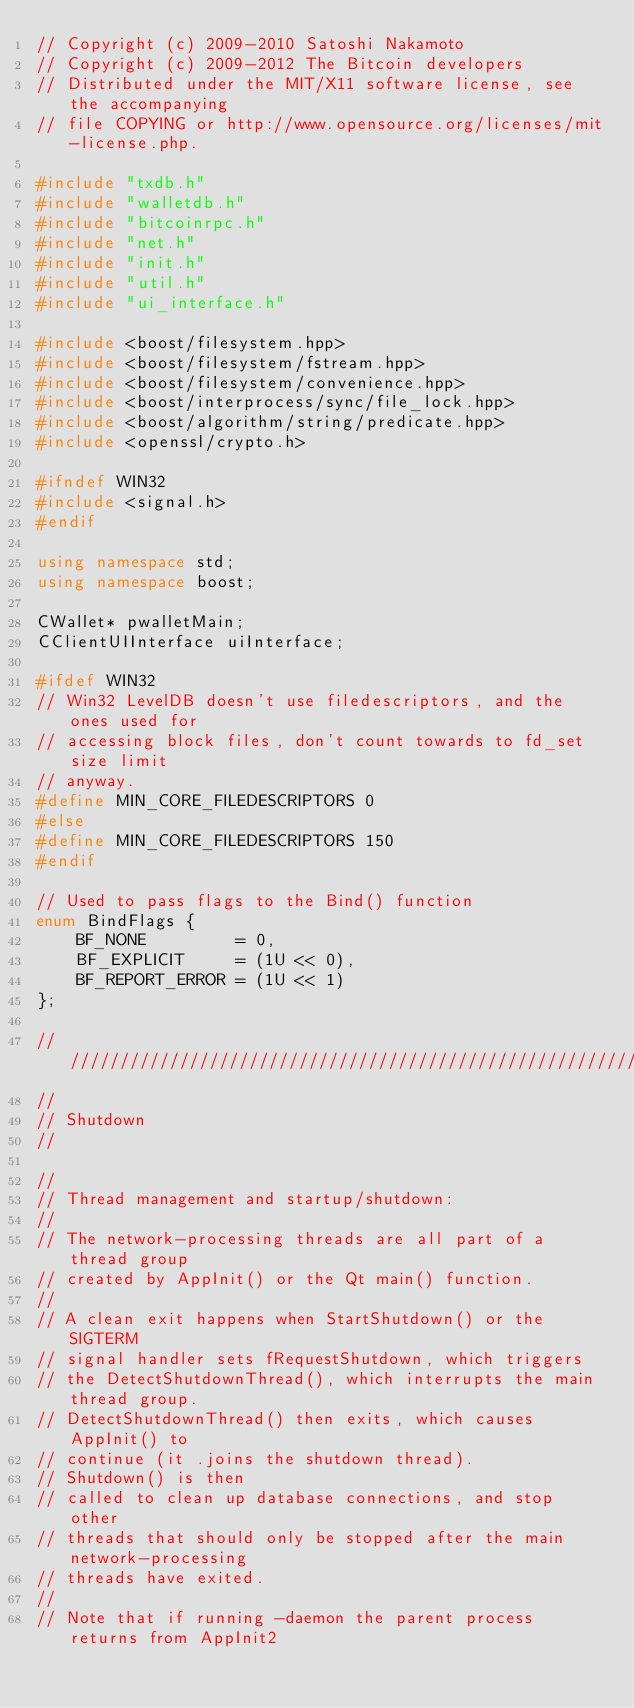Convert code to text. <code><loc_0><loc_0><loc_500><loc_500><_C++_>// Copyright (c) 2009-2010 Satoshi Nakamoto
// Copyright (c) 2009-2012 The Bitcoin developers
// Distributed under the MIT/X11 software license, see the accompanying
// file COPYING or http://www.opensource.org/licenses/mit-license.php.

#include "txdb.h"
#include "walletdb.h"
#include "bitcoinrpc.h"
#include "net.h"
#include "init.h"
#include "util.h"
#include "ui_interface.h"

#include <boost/filesystem.hpp>
#include <boost/filesystem/fstream.hpp>
#include <boost/filesystem/convenience.hpp>
#include <boost/interprocess/sync/file_lock.hpp>
#include <boost/algorithm/string/predicate.hpp>
#include <openssl/crypto.h>

#ifndef WIN32
#include <signal.h>
#endif

using namespace std;
using namespace boost;

CWallet* pwalletMain;
CClientUIInterface uiInterface;

#ifdef WIN32
// Win32 LevelDB doesn't use filedescriptors, and the ones used for
// accessing block files, don't count towards to fd_set size limit
// anyway.
#define MIN_CORE_FILEDESCRIPTORS 0
#else
#define MIN_CORE_FILEDESCRIPTORS 150
#endif

// Used to pass flags to the Bind() function
enum BindFlags {
    BF_NONE         = 0,
    BF_EXPLICIT     = (1U << 0),
    BF_REPORT_ERROR = (1U << 1)
};

//////////////////////////////////////////////////////////////////////////////
//
// Shutdown
//

//
// Thread management and startup/shutdown:
//
// The network-processing threads are all part of a thread group
// created by AppInit() or the Qt main() function.
//
// A clean exit happens when StartShutdown() or the SIGTERM
// signal handler sets fRequestShutdown, which triggers
// the DetectShutdownThread(), which interrupts the main thread group.
// DetectShutdownThread() then exits, which causes AppInit() to
// continue (it .joins the shutdown thread).
// Shutdown() is then
// called to clean up database connections, and stop other
// threads that should only be stopped after the main network-processing
// threads have exited.
//
// Note that if running -daemon the parent process returns from AppInit2</code> 